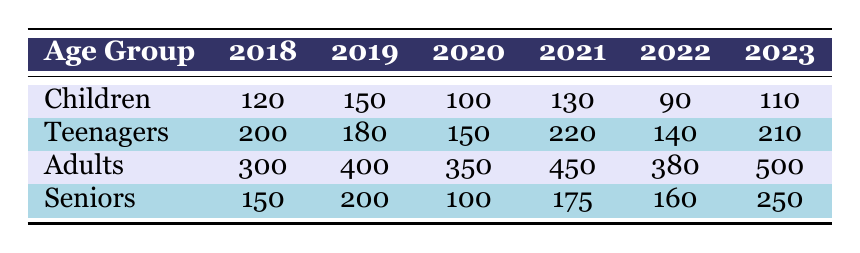What was the total attendance of children in 2020? In 2020, the table indicates that the attendance for children was 100.
Answer: 100 Which age group had the highest attendance in 2021? The table shows that adults had the highest attendance in 2021 with 450 participants.
Answer: Adults What is the difference in attendance for seniors between 2019 and 2023? The attendance for seniors in 2019 was 200 and in 2023 it was 250. The difference is 250 - 200 = 50.
Answer: 50 What was the average attendance for teenagers from 2018 to 2022? The attendance numbers for teenagers in those years are 200, 180, 150, 220, and 140. Summing these gives 200 + 180 + 150 + 220 + 140 = 1090. Dividing this by 5 (the total years) gives an average of 1090 / 5 = 218.
Answer: 218 Did attendance for adults increase every year from 2018 to 2023? Analyzing the attendance: 300 in 2018, 400 in 2019, 350 in 2020 (a decrease), 450 in 2021, 380 in 2022 (a decrease), and 500 in 2023 (an increase). Since there were decreases in two years, the statement is false.
Answer: No Which event had the least attendance for children, and what was that number? The table shows children's attendance over the years with 90 in 2022 being the least compared to the other years.
Answer: 90 What is the total attendance across all age groups for the Renaissance Fair in 2021? The attendance numbers for the Renaissance Fair are: children 130, teenagers 220, adults 450, and seniors 175. Adding these gives 130 + 220 + 450 + 175 = 975.
Answer: 975 What age group saw a decline in attendance in 2022 compared to 2021? The table shows that attendance for children (130 to 90) and for teenagers (220 to 140) both decreased from 2021 to 2022.
Answer: Children and Teenagers Which year had the highest total attendance across all age groups? Adding the total attendance for each year: 2018 (120+200+300+150 = 770), 2019 (150+180+400+200 = 930), 2020 (100+150+350+100 = 700), 2021 (130+220+450+175 = 975), 2022 (90+140+380+160 = 770), and 2023 (110+210+500+250 = 1070). The highest total was in 2023.
Answer: 2023 